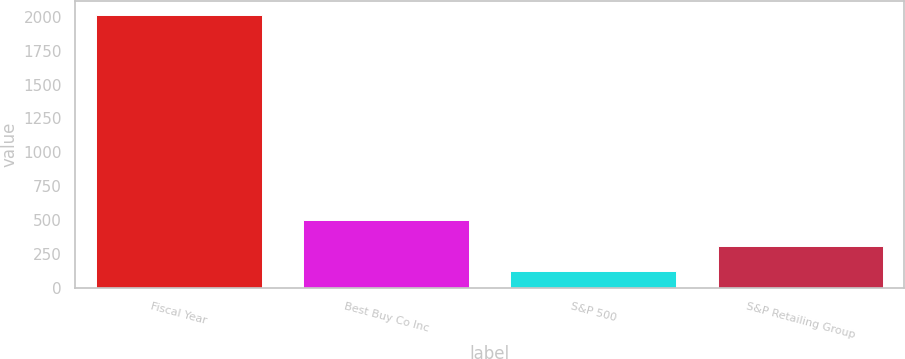Convert chart to OTSL. <chart><loc_0><loc_0><loc_500><loc_500><bar_chart><fcel>Fiscal Year<fcel>Best Buy Co Inc<fcel>S&P 500<fcel>S&P Retailing Group<nl><fcel>2014<fcel>500.02<fcel>121.52<fcel>310.77<nl></chart> 